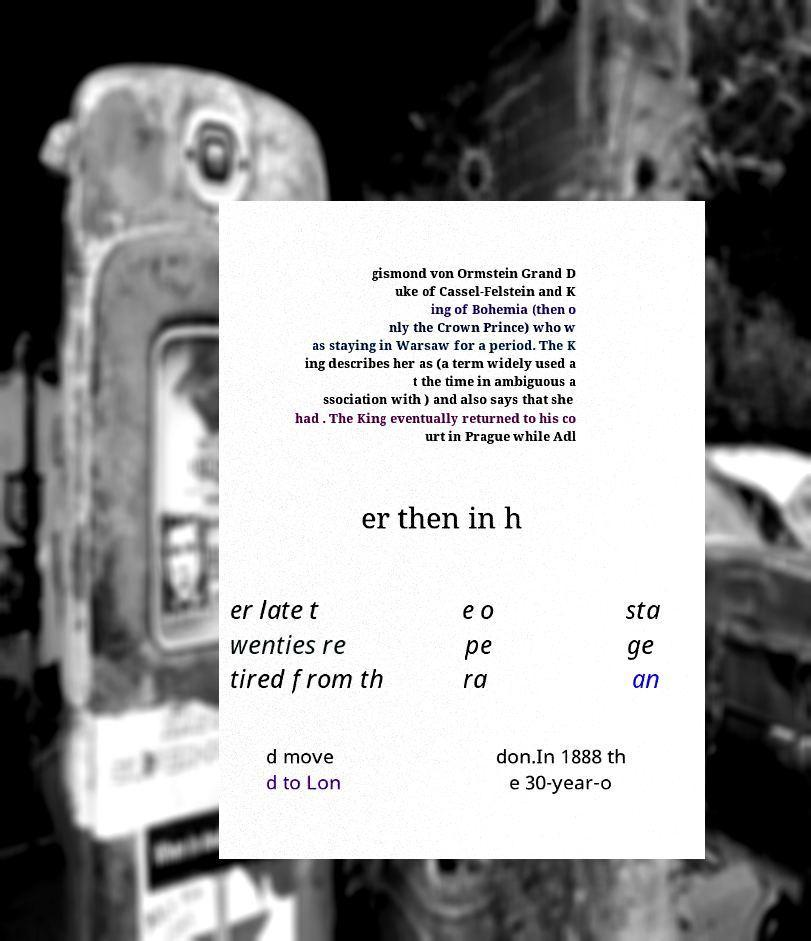Please identify and transcribe the text found in this image. gismond von Ormstein Grand D uke of Cassel-Felstein and K ing of Bohemia (then o nly the Crown Prince) who w as staying in Warsaw for a period. The K ing describes her as (a term widely used a t the time in ambiguous a ssociation with ) and also says that she had . The King eventually returned to his co urt in Prague while Adl er then in h er late t wenties re tired from th e o pe ra sta ge an d move d to Lon don.In 1888 th e 30-year-o 